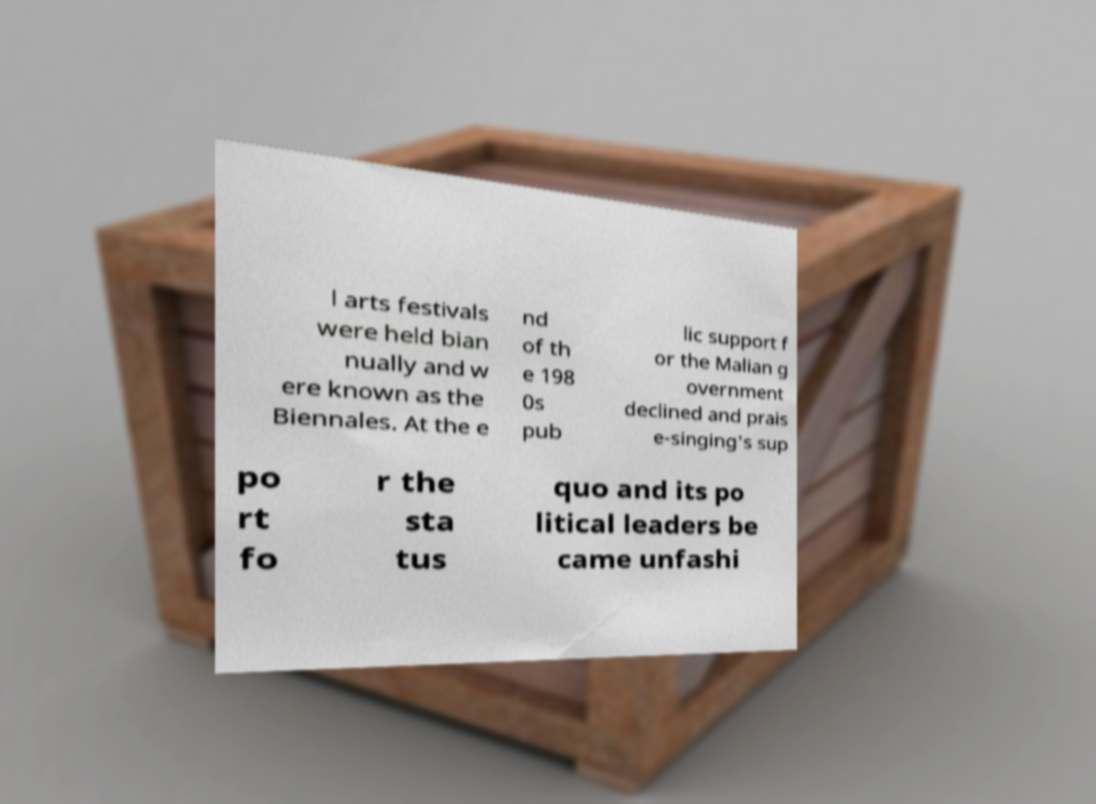There's text embedded in this image that I need extracted. Can you transcribe it verbatim? l arts festivals were held bian nually and w ere known as the Biennales. At the e nd of th e 198 0s pub lic support f or the Malian g overnment declined and prais e-singing's sup po rt fo r the sta tus quo and its po litical leaders be came unfashi 